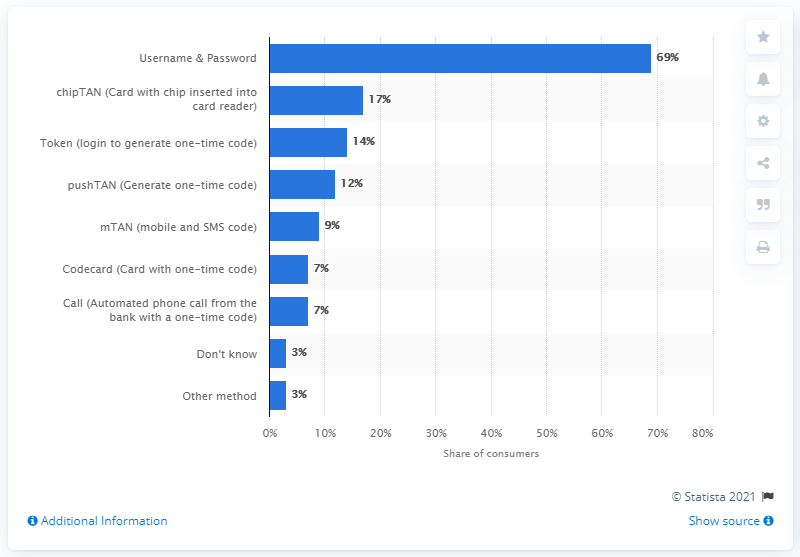Outline some significant characteristics in this image. According to a recent study, 69% of consumers in the UK use a username and password when logging into online banking. 